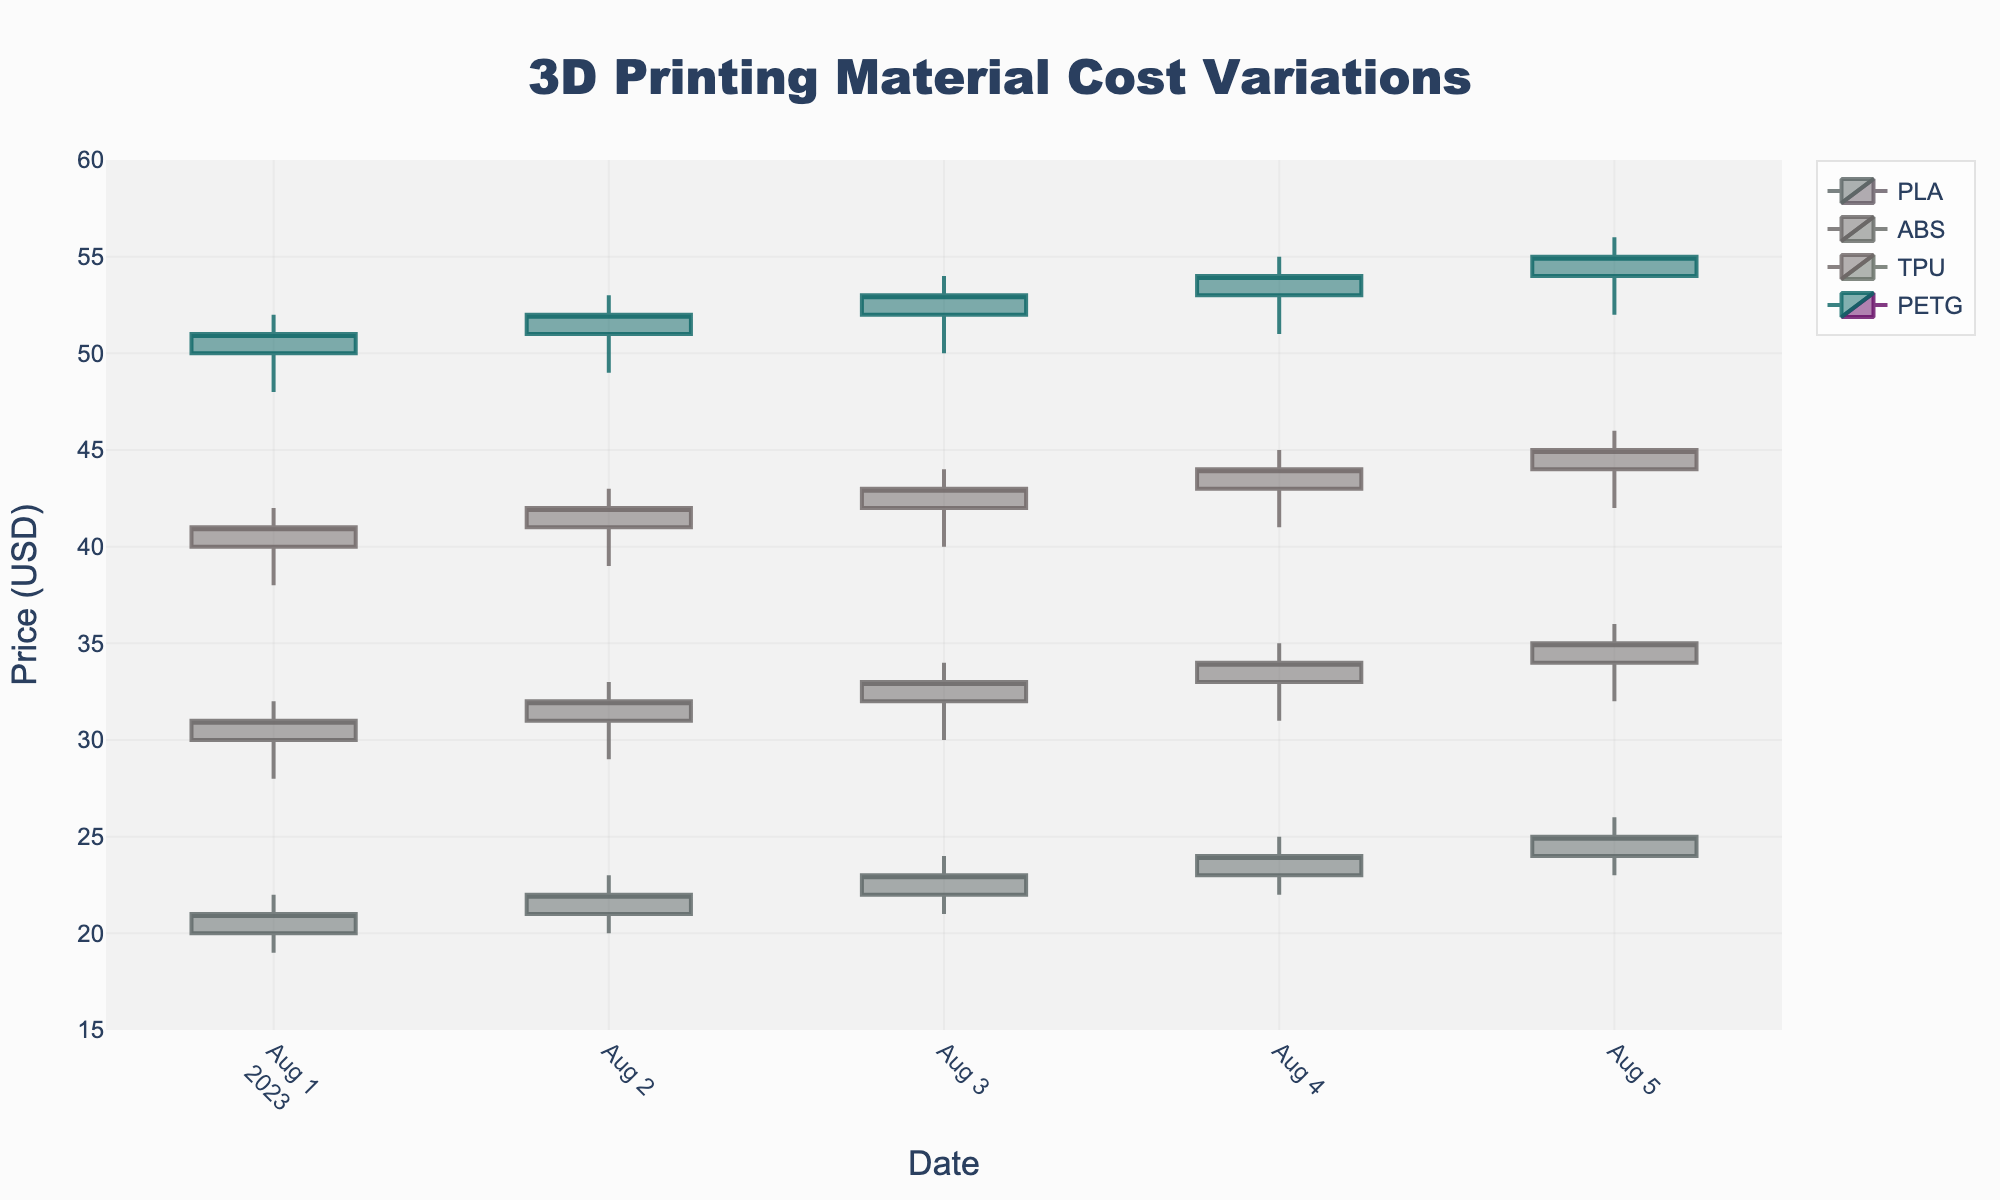What's the title of the plot? The title is usually displayed prominently at the top of the figure. In this case, it should read '3D Printing Material Cost Variations' as specified in the plotting code.
Answer: 3D Printing Material Cost Variations What is the price range shown on the y-axis? The y-axis range is defined in the plotting code. It spans from 15 to 60, as specified by the `range` parameter in the `yaxis` settings.
Answer: 15 to 60 Compare the price trends between PLA and TPU. Which material showed a larger increase in closing price over the period? First, look at both PLA and TPU materials separately. For PLA, the closing price goes from 21 to 25. For TPU, the closing price goes from 41 to 45. Calculate the differences: 25 - 21 = 4 for PLA, and 45 - 41 = 4 for TPU. Both materials showed the same increase.
Answer: Both showed an increase of 4 Which material had the highest closing price on August 5, 2023? Look at the data for August 5, 2023, and check which material has the highest 'Close' value. PETG has the highest closing price of 55 on this date.
Answer: PETG What was the closing price for ABS on August 3, 2023? Locate the candlestick for ABS on August 3, 2023, and check the closing price, which is 33.
Answer: 33 Between PLA and ABS, which one had greater volatility on August 4, 2023? Volatility can be measured by the range between the high and low prices. For PLA on August 4, the range is 25 - 22 = 3. For ABS, the range is 35 - 31 = 4. ABS had greater volatility on that date.
Answer: ABS Identify the supplier for TPU material. The supplier is usually labeled, or in the given data and settings, TPU is supplied by Creality.
Answer: Creality For PETG supplied by MatterHackers, how much did the closing price change from August 1 to August 5? Look at the closing prices for PETG on August 1 (51) and August 5 (55). The change is 55 - 51, which equals an increase of 4 dollars.
Answer: 4 Which material had the highest increase in closing price over the period from August 1 to August 5? Calculate the closing price difference for each material over the specified period: PLA (25-21=4), ABS (35-31=4), TPU (45-41=4), and PETG (55-51=4). All materials had an equal increase in closing price.
Answer: All materials How did the closing price of PLA change from August 1 to August 4? Check PLA’s closing prices from August 1 (21) to August 4 (24). The change is 24 - 21, which is an increase of 3.
Answer: Increased by 3 